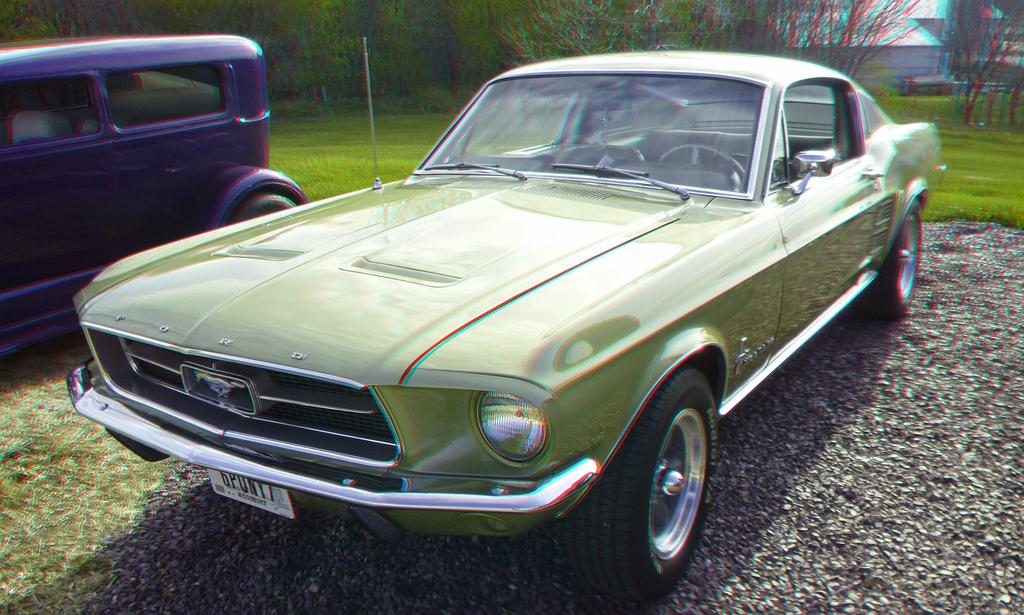How many cars are present in the image? There are two cars in the image. What is the ground covered with in the image? The ground is covered with green grass. What can be seen in the background of the image? There are green color trees in the background of the image. What type of ornament is hanging from the trees in the image? There are no ornaments hanging from the trees in the image; only green color trees are visible in the background. 